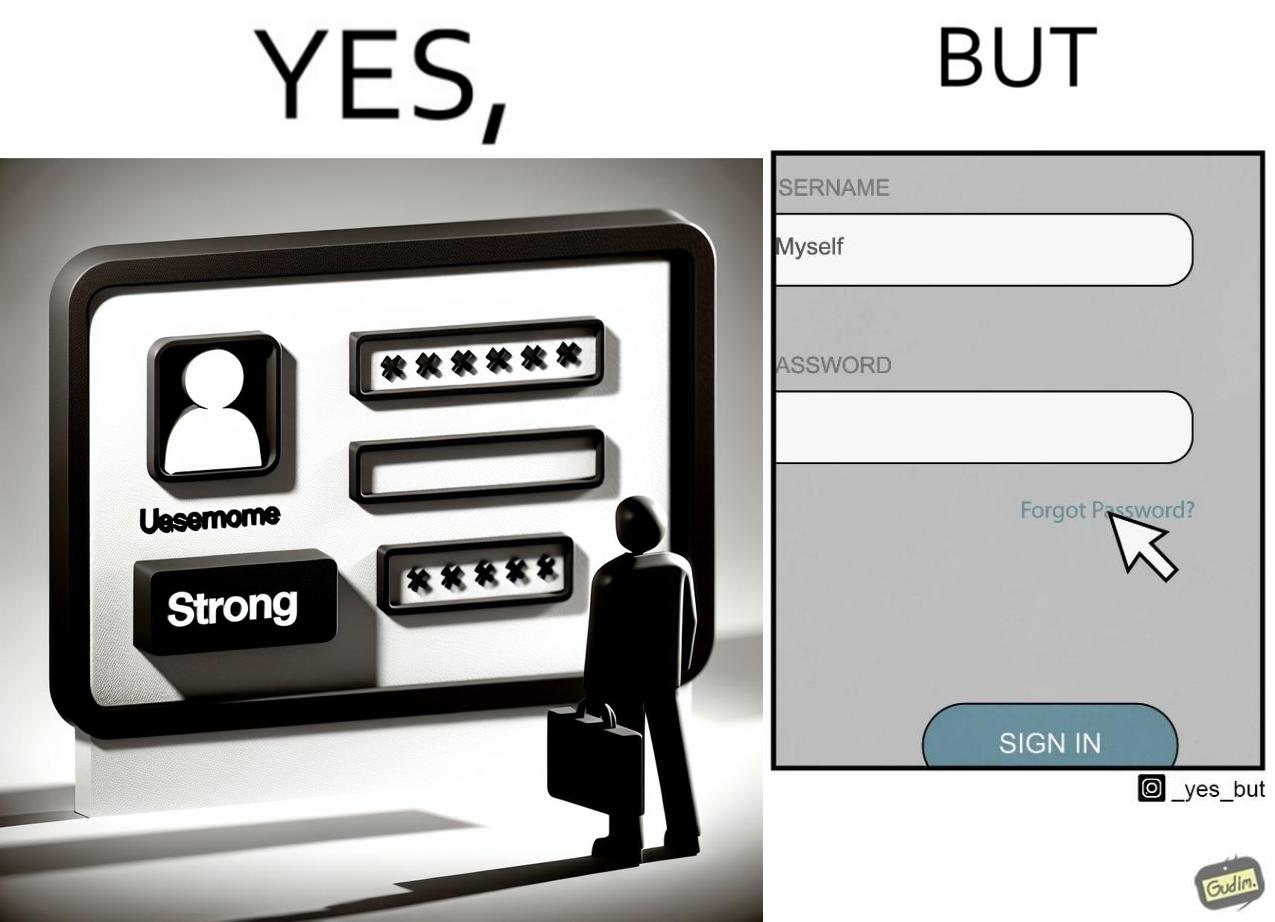Describe what you see in this image. The image is ironic, because people set such a strong passwords for their accounts that they even forget the password and need to reset them 